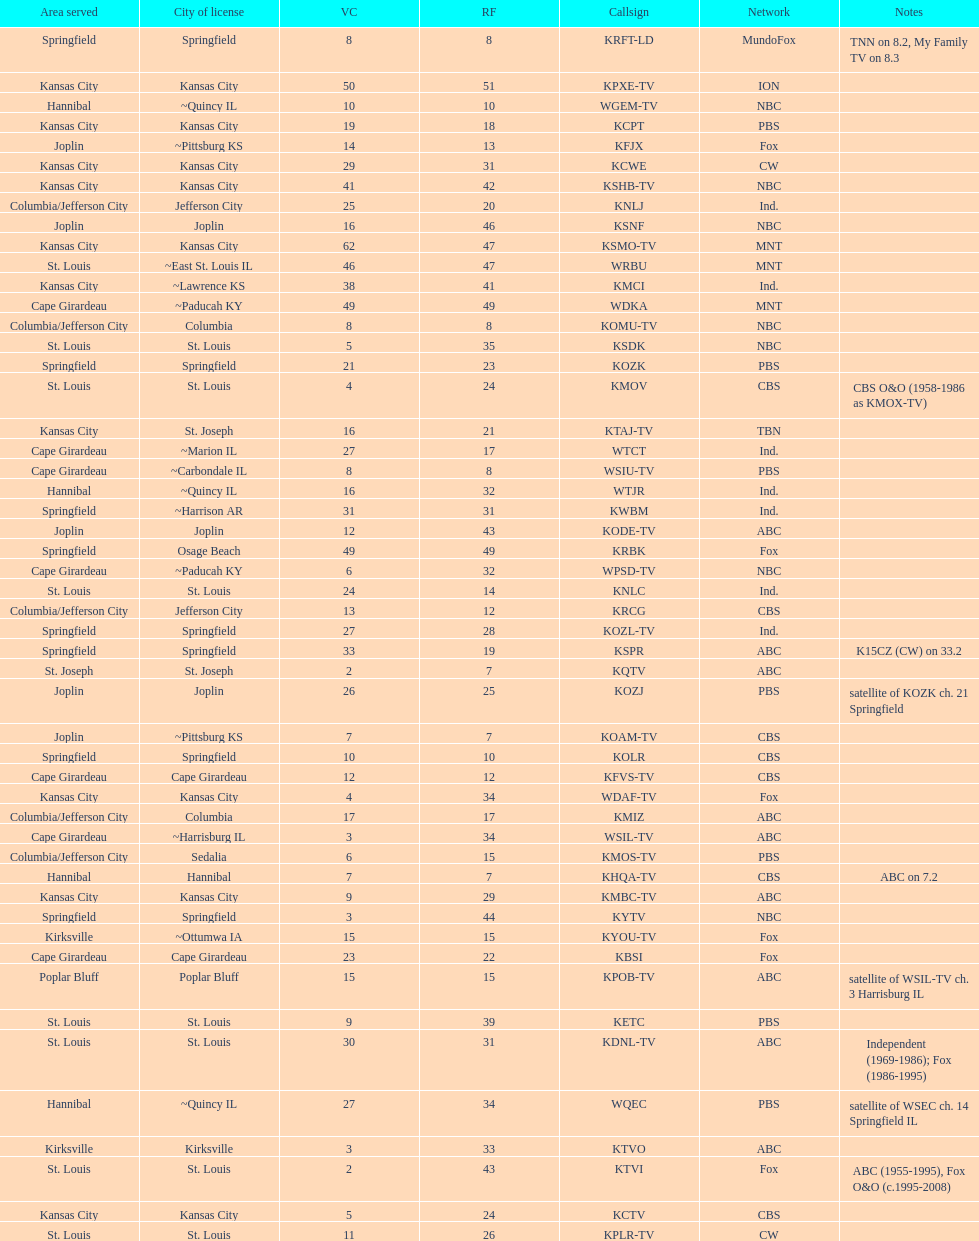How many of these missouri tv stations are actually licensed in a city in illinois (il)? 7. 